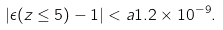<formula> <loc_0><loc_0><loc_500><loc_500>| \epsilon ( z \leq 5 ) - 1 | < a 1 . 2 \times 1 0 ^ { - 9 } .</formula> 